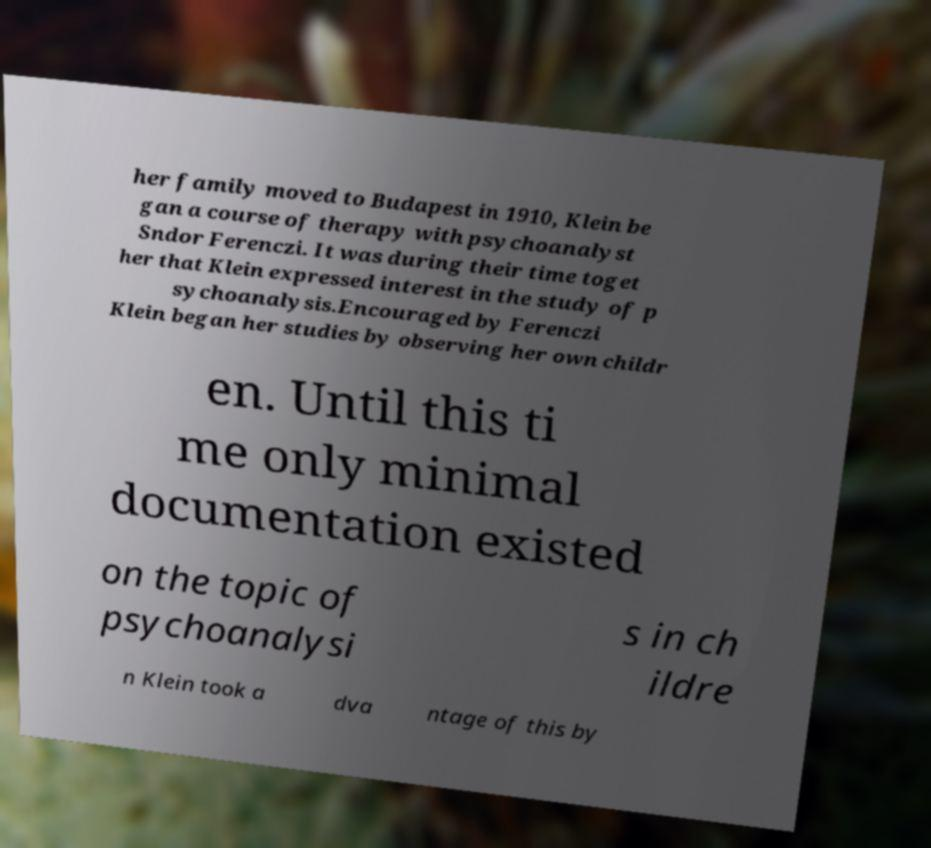For documentation purposes, I need the text within this image transcribed. Could you provide that? her family moved to Budapest in 1910, Klein be gan a course of therapy with psychoanalyst Sndor Ferenczi. It was during their time toget her that Klein expressed interest in the study of p sychoanalysis.Encouraged by Ferenczi Klein began her studies by observing her own childr en. Until this ti me only minimal documentation existed on the topic of psychoanalysi s in ch ildre n Klein took a dva ntage of this by 